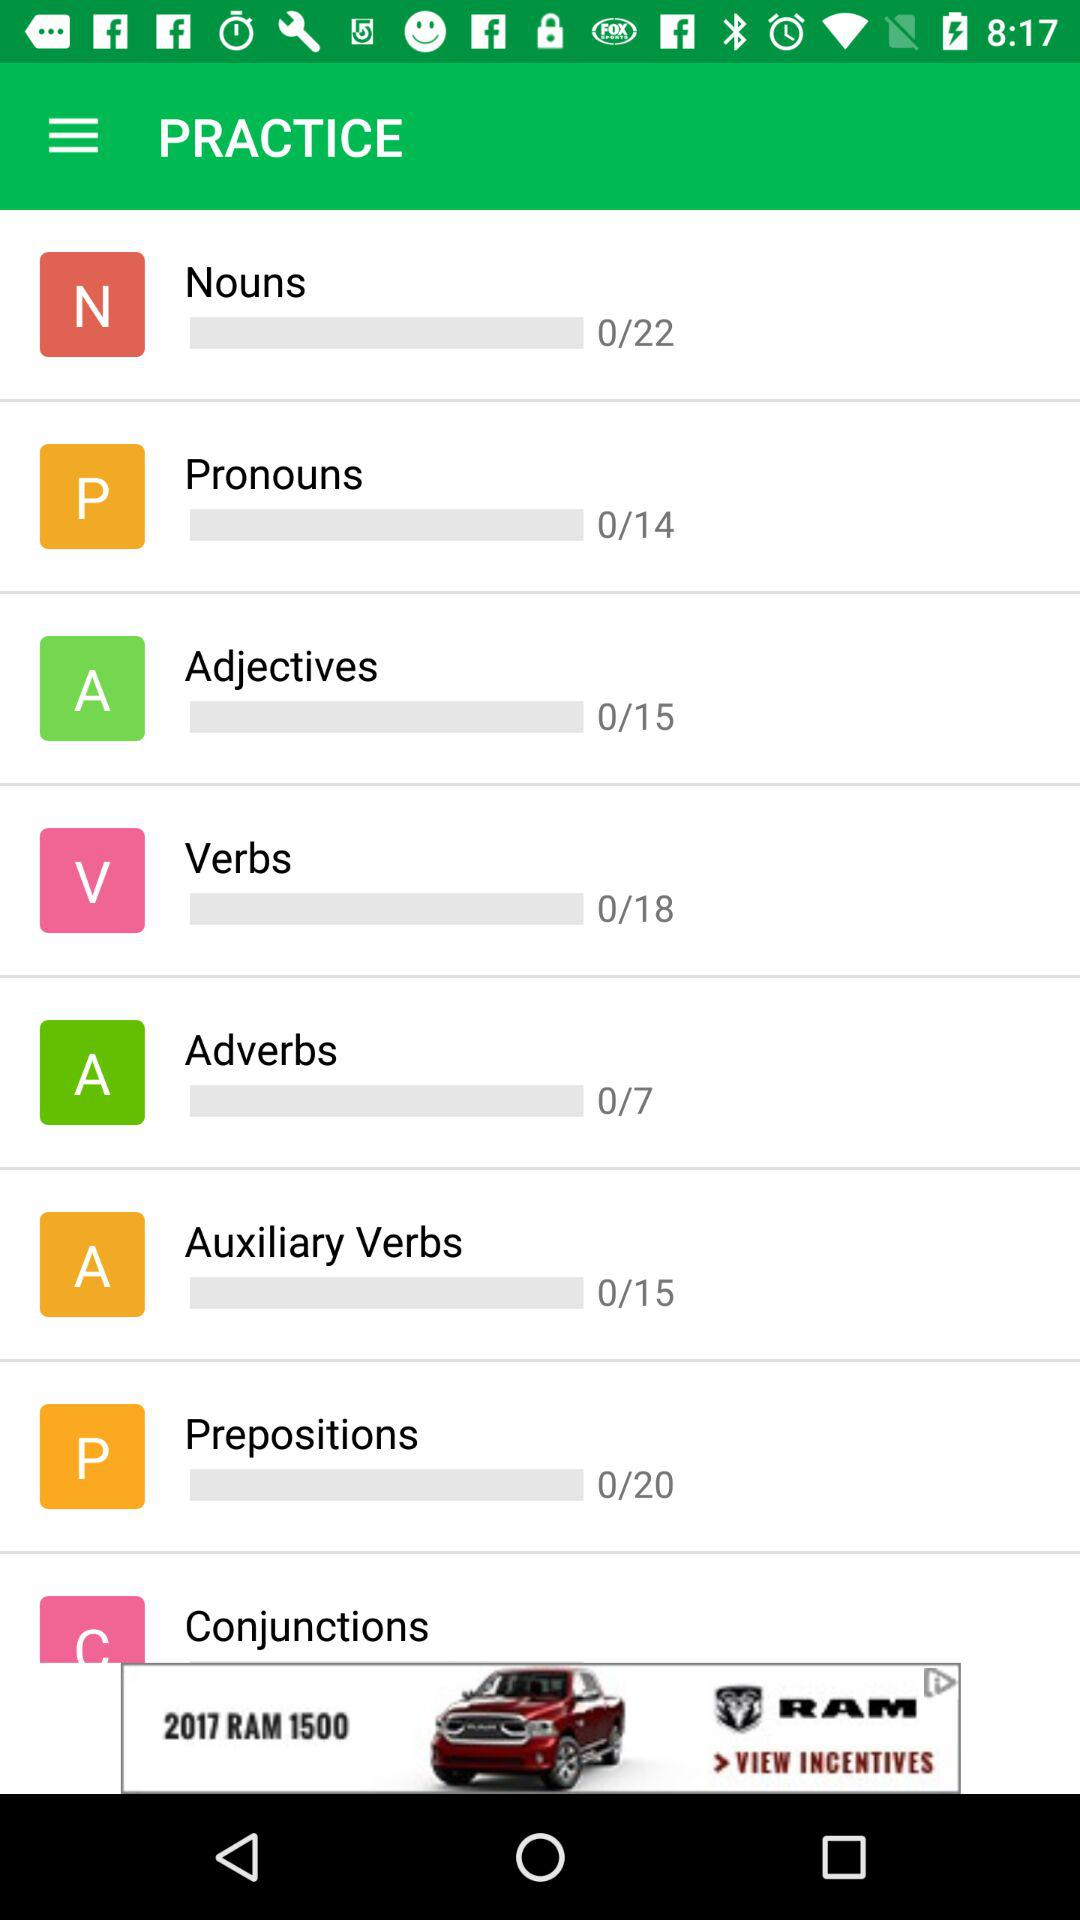What is the total number of "Nouns"? The total number of "Nouns" is 22. 